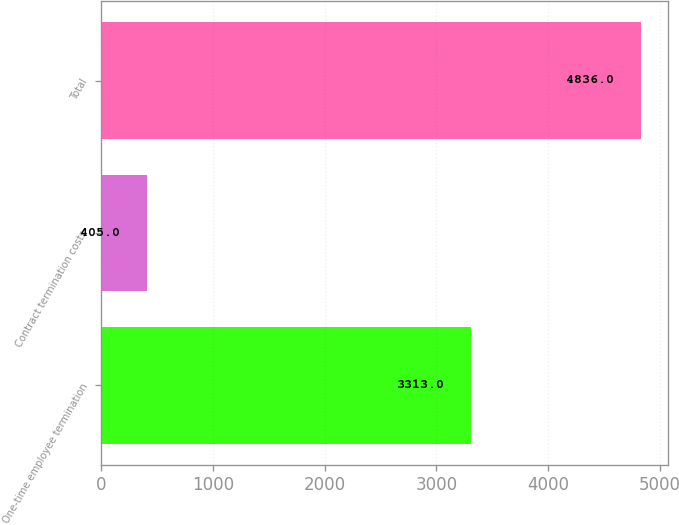Convert chart. <chart><loc_0><loc_0><loc_500><loc_500><bar_chart><fcel>One-time employee termination<fcel>Contract termination costs<fcel>Total<nl><fcel>3313<fcel>405<fcel>4836<nl></chart> 